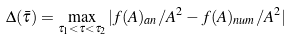Convert formula to latex. <formula><loc_0><loc_0><loc_500><loc_500>\Delta ( \bar { \tau } ) = \max _ { \tau _ { 1 } < \tau < \tau _ { 2 } } | f ( A ) _ { a n } / A ^ { 2 } - f ( A ) _ { n u m } / A ^ { 2 } |</formula> 